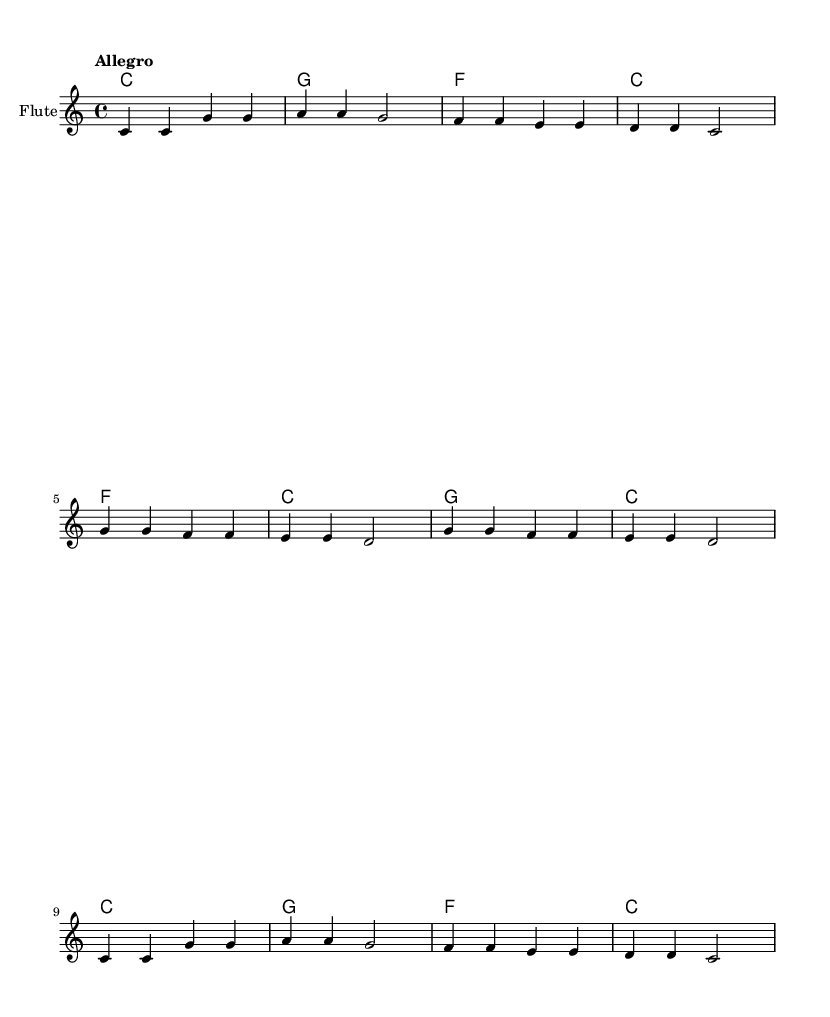What is the key signature of this music? The key signature is C major, which has no sharps or flats.
Answer: C major What is the time signature of this music? The time signature is indicated by the "4/4" at the beginning, representing four beats per measure with a quarter note receiving one beat.
Answer: 4/4 What tempo marking is used in this piece? The tempo marking is "Allegro," which indicates a fast and lively pace.
Answer: Allegro How many measures are in the melody? By counting the distinct sequences separated by vertical lines (bar lines) in the melody part, there are 12 measures total.
Answer: 12 What is the first lyric phrase of the song? The first lyrics line of the song is "Wash, wash, wash your hands," as seen at the beginning of the lyrics section.
Answer: Wash, wash, wash your hands Which word indicates the action to be performed on the hands in the lyrics? The action verb in the lyrics that indicates what to do with the hands is "wash," repeated multiple times.
Answer: wash How many chords are indicated in the chord progression? The chord progression shows a total of 8 chords, as each chord is represented in its own vertical section.
Answer: 8 